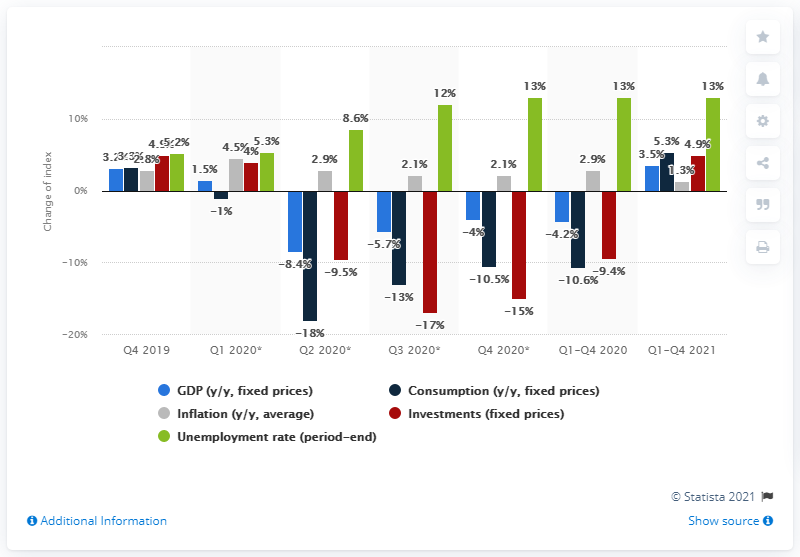Mention a couple of crucial points in this snapshot. The expected unemployment rate by the end of 2020 is 13.. The inflation rate is expected to reach 2.1% by the end of 2020, according to forecasts. 